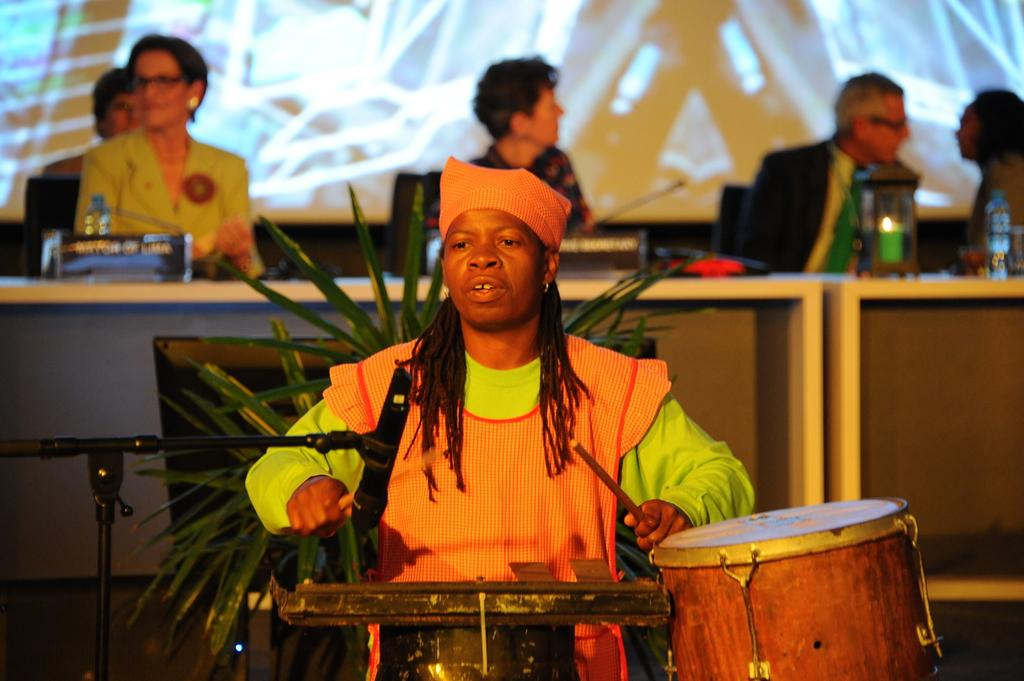What is the main activity being performed by the person in the image? The person in the image is playing drums. What object is in front of the drum player? The drum player has a microphone in front of them. Can you describe the audience in the image? There are many people sitting behind the drum player. How many thumbs does the judge have in the image? There is no judge present in the image, and therefore no thumbs to count. 